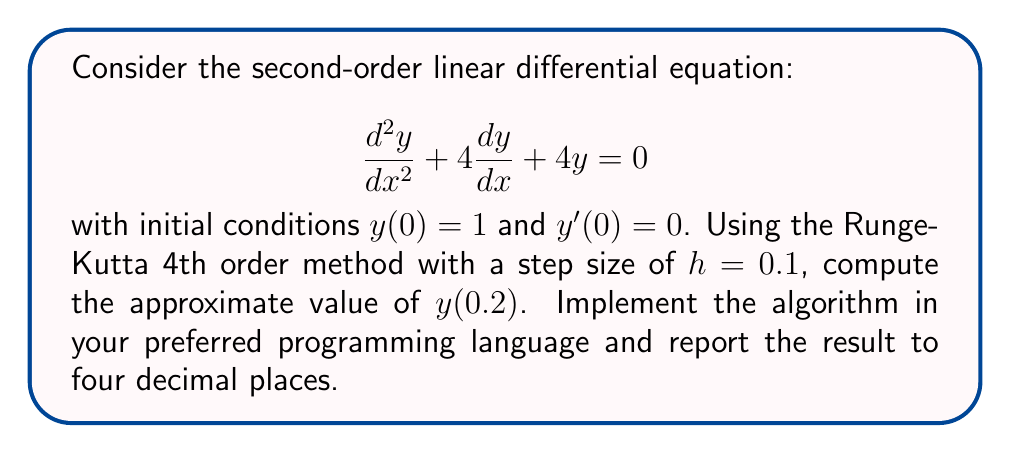Provide a solution to this math problem. To solve this problem using the Runge-Kutta 4th order method (RK4), we need to convert the second-order differential equation into a system of two first-order equations:

Let $y_1 = y$ and $y_2 = \frac{dy}{dx}$. Then:

$$\frac{dy_1}{dx} = y_2$$
$$\frac{dy_2}{dx} = -4y_2 - 4y_1$$

The RK4 method for a system of two equations is:

$$k_{1,1} = hf_1(x_n, y_{1,n}, y_{2,n})$$
$$k_{1,2} = hf_2(x_n, y_{1,n}, y_{2,n})$$
$$k_{2,1} = hf_1(x_n + \frac{h}{2}, y_{1,n} + \frac{k_{1,1}}{2}, y_{2,n} + \frac{k_{1,2}}{2})$$
$$k_{2,2} = hf_2(x_n + \frac{h}{2}, y_{1,n} + \frac{k_{1,1}}{2}, y_{2,n} + \frac{k_{1,2}}{2})$$
$$k_{3,1} = hf_1(x_n + \frac{h}{2}, y_{1,n} + \frac{k_{2,1}}{2}, y_{2,n} + \frac{k_{2,2}}{2})$$
$$k_{3,2} = hf_2(x_n + \frac{h}{2}, y_{1,n} + \frac{k_{2,1}}{2}, y_{2,n} + \frac{k_{2,2}}{2})$$
$$k_{4,1} = hf_1(x_n + h, y_{1,n} + k_{3,1}, y_{2,n} + k_{3,2})$$
$$k_{4,2} = hf_2(x_n + h, y_{1,n} + k_{3,1}, y_{2,n} + k_{3,2})$$

$$y_{1,n+1} = y_{1,n} + \frac{1}{6}(k_{1,1} + 2k_{2,1} + 2k_{3,1} + k_{4,1})$$
$$y_{2,n+1} = y_{2,n} + \frac{1}{6}(k_{1,2} + 2k_{2,2} + 2k_{3,2} + k_{4,2})$$

Where $f_1(x, y_1, y_2) = y_2$ and $f_2(x, y_1, y_2) = -4y_2 - 4y_1$.

To compute $y(0.2)$, we need to perform two iterations with $h = 0.1$, starting from the initial conditions $y_1(0) = 1$ and $y_2(0) = 0$.

Implementing this algorithm in a programming language (e.g., Python) and running it for two iterations will give us the approximate value of $y(0.2)$.
Answer: $y(0.2) \approx 0.8187$ (to four decimal places) 